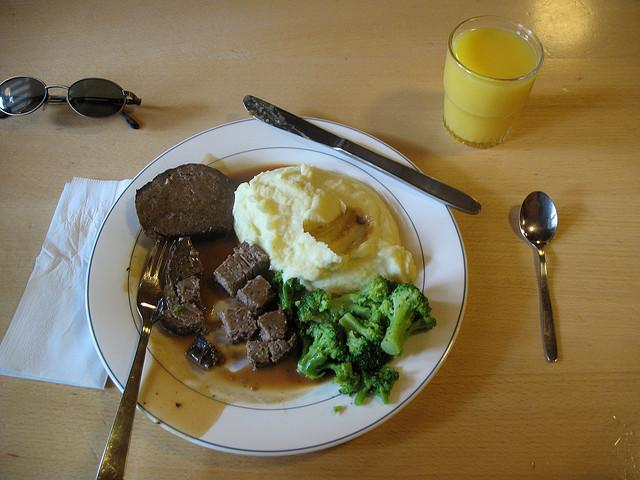Which food on the plate is highest carbohydrates? Please explain your reasoning. potatoes. The white mass present on this plate is mashed potatoes. this vegetable is known for it's high carbohydrate content. 